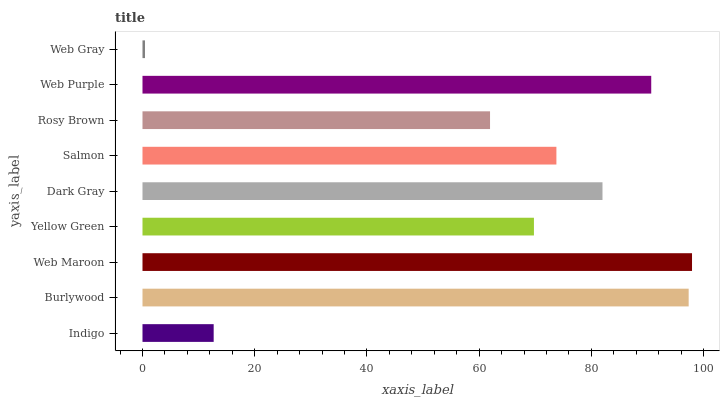Is Web Gray the minimum?
Answer yes or no. Yes. Is Web Maroon the maximum?
Answer yes or no. Yes. Is Burlywood the minimum?
Answer yes or no. No. Is Burlywood the maximum?
Answer yes or no. No. Is Burlywood greater than Indigo?
Answer yes or no. Yes. Is Indigo less than Burlywood?
Answer yes or no. Yes. Is Indigo greater than Burlywood?
Answer yes or no. No. Is Burlywood less than Indigo?
Answer yes or no. No. Is Salmon the high median?
Answer yes or no. Yes. Is Salmon the low median?
Answer yes or no. Yes. Is Rosy Brown the high median?
Answer yes or no. No. Is Burlywood the low median?
Answer yes or no. No. 